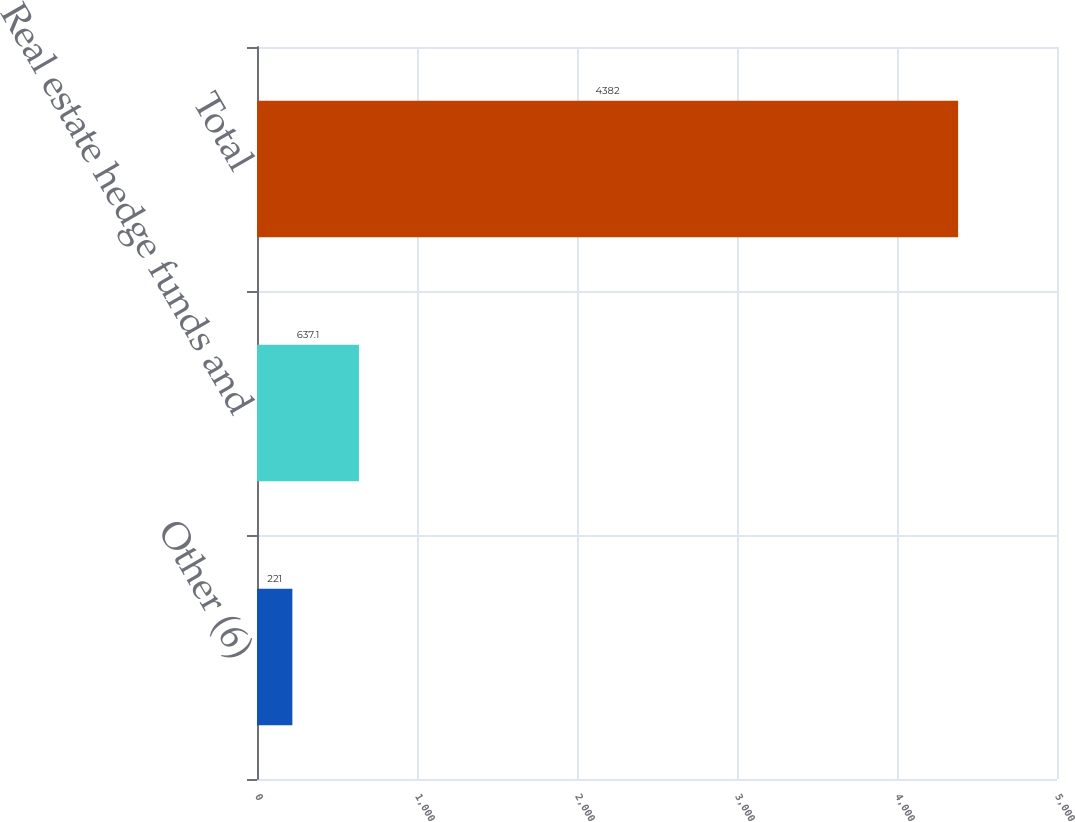<chart> <loc_0><loc_0><loc_500><loc_500><bar_chart><fcel>Other (6)<fcel>Real estate hedge funds and<fcel>Total<nl><fcel>221<fcel>637.1<fcel>4382<nl></chart> 